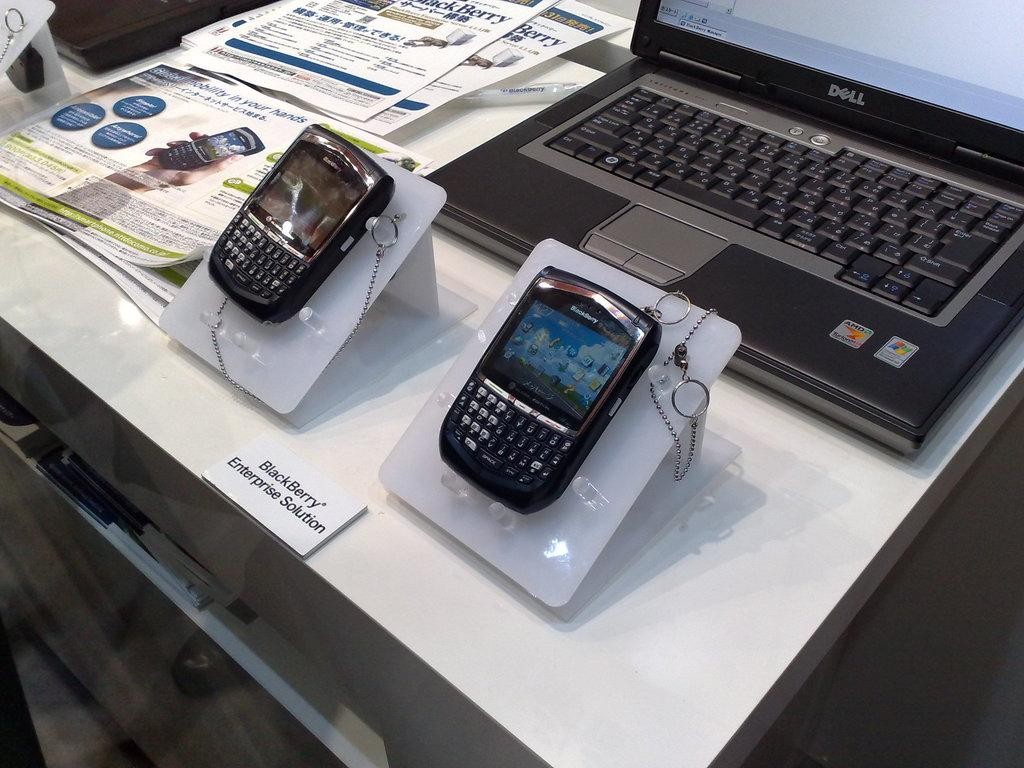<image>
Present a compact description of the photo's key features. The display for BlackBerry Enterprise Solution has a laptop and two phones. 